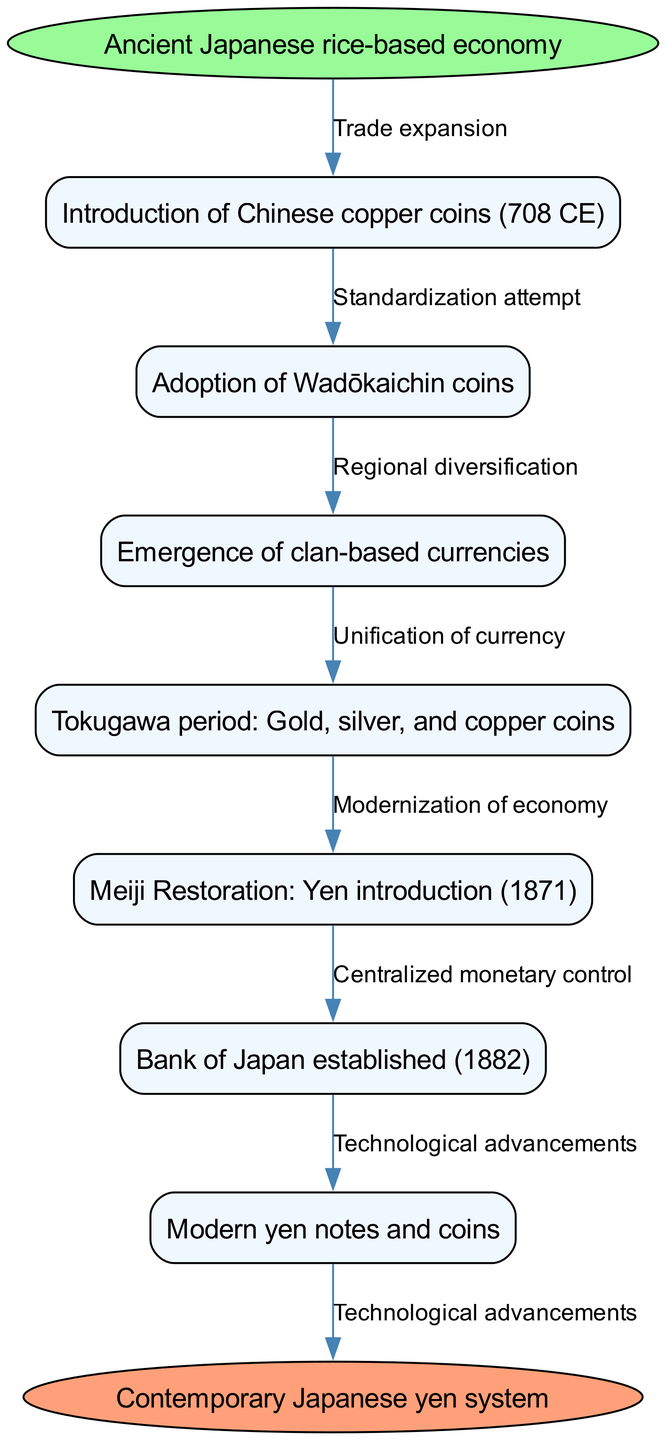What is the first node in the diagram? The first node of the flow chart indicates the starting point, labeled as "Ancient Japanese rice-based economy."
Answer: Ancient Japanese rice-based economy How many nodes are there in total? Counting the number of nodes listed in the diagram, we find there are 7 intermediate nodes plus the start and end nodes, which gives us a total of 9 nodes.
Answer: 9 What edge connects the start node to the first intermediate node? The edge connecting the start node to the first intermediate node is labeled "Trade expansion."
Answer: Trade expansion Which period introduced the yen? Referring to the relevant node, the "Meiji Restoration: Yen introduction (1871)" indicates the introduction of the yen.
Answer: 1871 What does the last edge represent? The last edge connecting the final node to the contemporary system is labeled "Technological advancements," indicating a modern influence on the currency system.
Answer: Technological advancements What were the currencies used during the Tokugawa period? The node labeled "Tokugawa period: Gold, silver, and copper coins" specifically states the types of currencies used during this period.
Answer: Gold, silver, and copper coins What significant change occurred after the establishment of the Bank of Japan in 1882? The following node, "Modern yen notes and coins," indicates that modern currency forms began to emerge after the establishment of the Bank of Japan.
Answer: Modern yen notes and coins How are regional currencies represented in the flow? The node "Emergence of clan-based currencies" shows that there was a diversification in how currencies were represented across different clans before standardization.
Answer: Clan-based currencies Which two nodes indicate a movement towards centralization in currency? The nodes "Bank of Japan established (1882)" and "Modernization of economy" indicate a move towards a centralized monetary system.
Answer: Bank of Japan established, Modernization of economy 